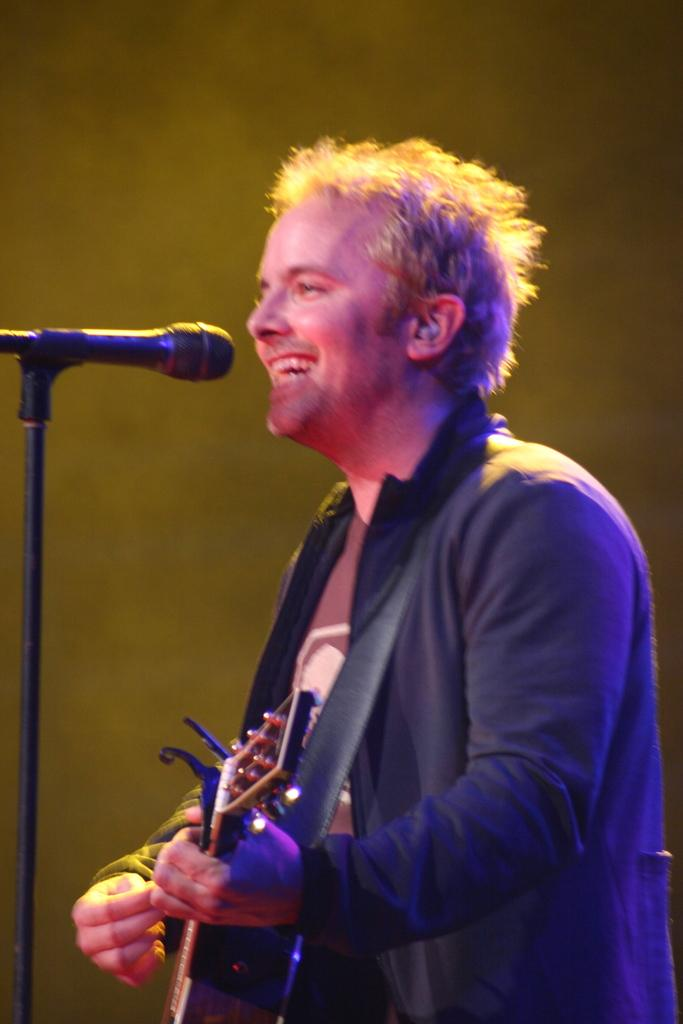What is the main subject of the image? There is a person in the image. Where is the person located in the image? The person is standing in the center. What is the person doing in the image? The person is playing a guitar and singing on a microphone. How does the person appear in the image? The person has a pretty smile on their face. Can you see the person's friend playing a piano in the image? There is no friend or piano present in the image; it only shows a person playing a guitar and singing on a microphone. 